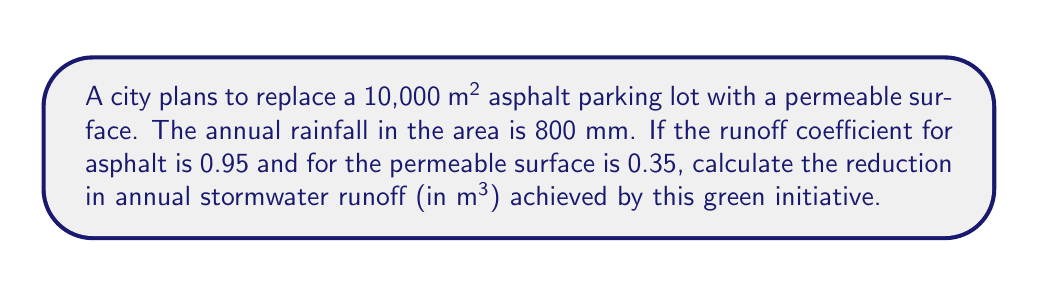Show me your answer to this math problem. To solve this problem, we'll follow these steps:

1) First, calculate the total annual rainfall volume:
   $V_{total} = \text{Area} \times \text{Annual Rainfall}$
   $V_{total} = 10,000 \text{ m}^2 \times 0.8 \text{ m} = 8,000 \text{ m}^3$

2) Calculate runoff volume for asphalt:
   $V_{asphalt} = V_{total} \times \text{Runoff Coefficient}_{asphalt}$
   $V_{asphalt} = 8,000 \text{ m}^3 \times 0.95 = 7,600 \text{ m}^3$

3) Calculate runoff volume for permeable surface:
   $V_{permeable} = V_{total} \times \text{Runoff Coefficient}_{permeable}$
   $V_{permeable} = 8,000 \text{ m}^3 \times 0.35 = 2,800 \text{ m}^3$

4) Calculate the reduction in runoff:
   $V_{reduction} = V_{asphalt} - V_{permeable}$
   $V_{reduction} = 7,600 \text{ m}^3 - 2,800 \text{ m}^3 = 4,800 \text{ m}^3$

Therefore, replacing the asphalt parking lot with a permeable surface will reduce annual stormwater runoff by 4,800 m³.
Answer: 4,800 m³ 